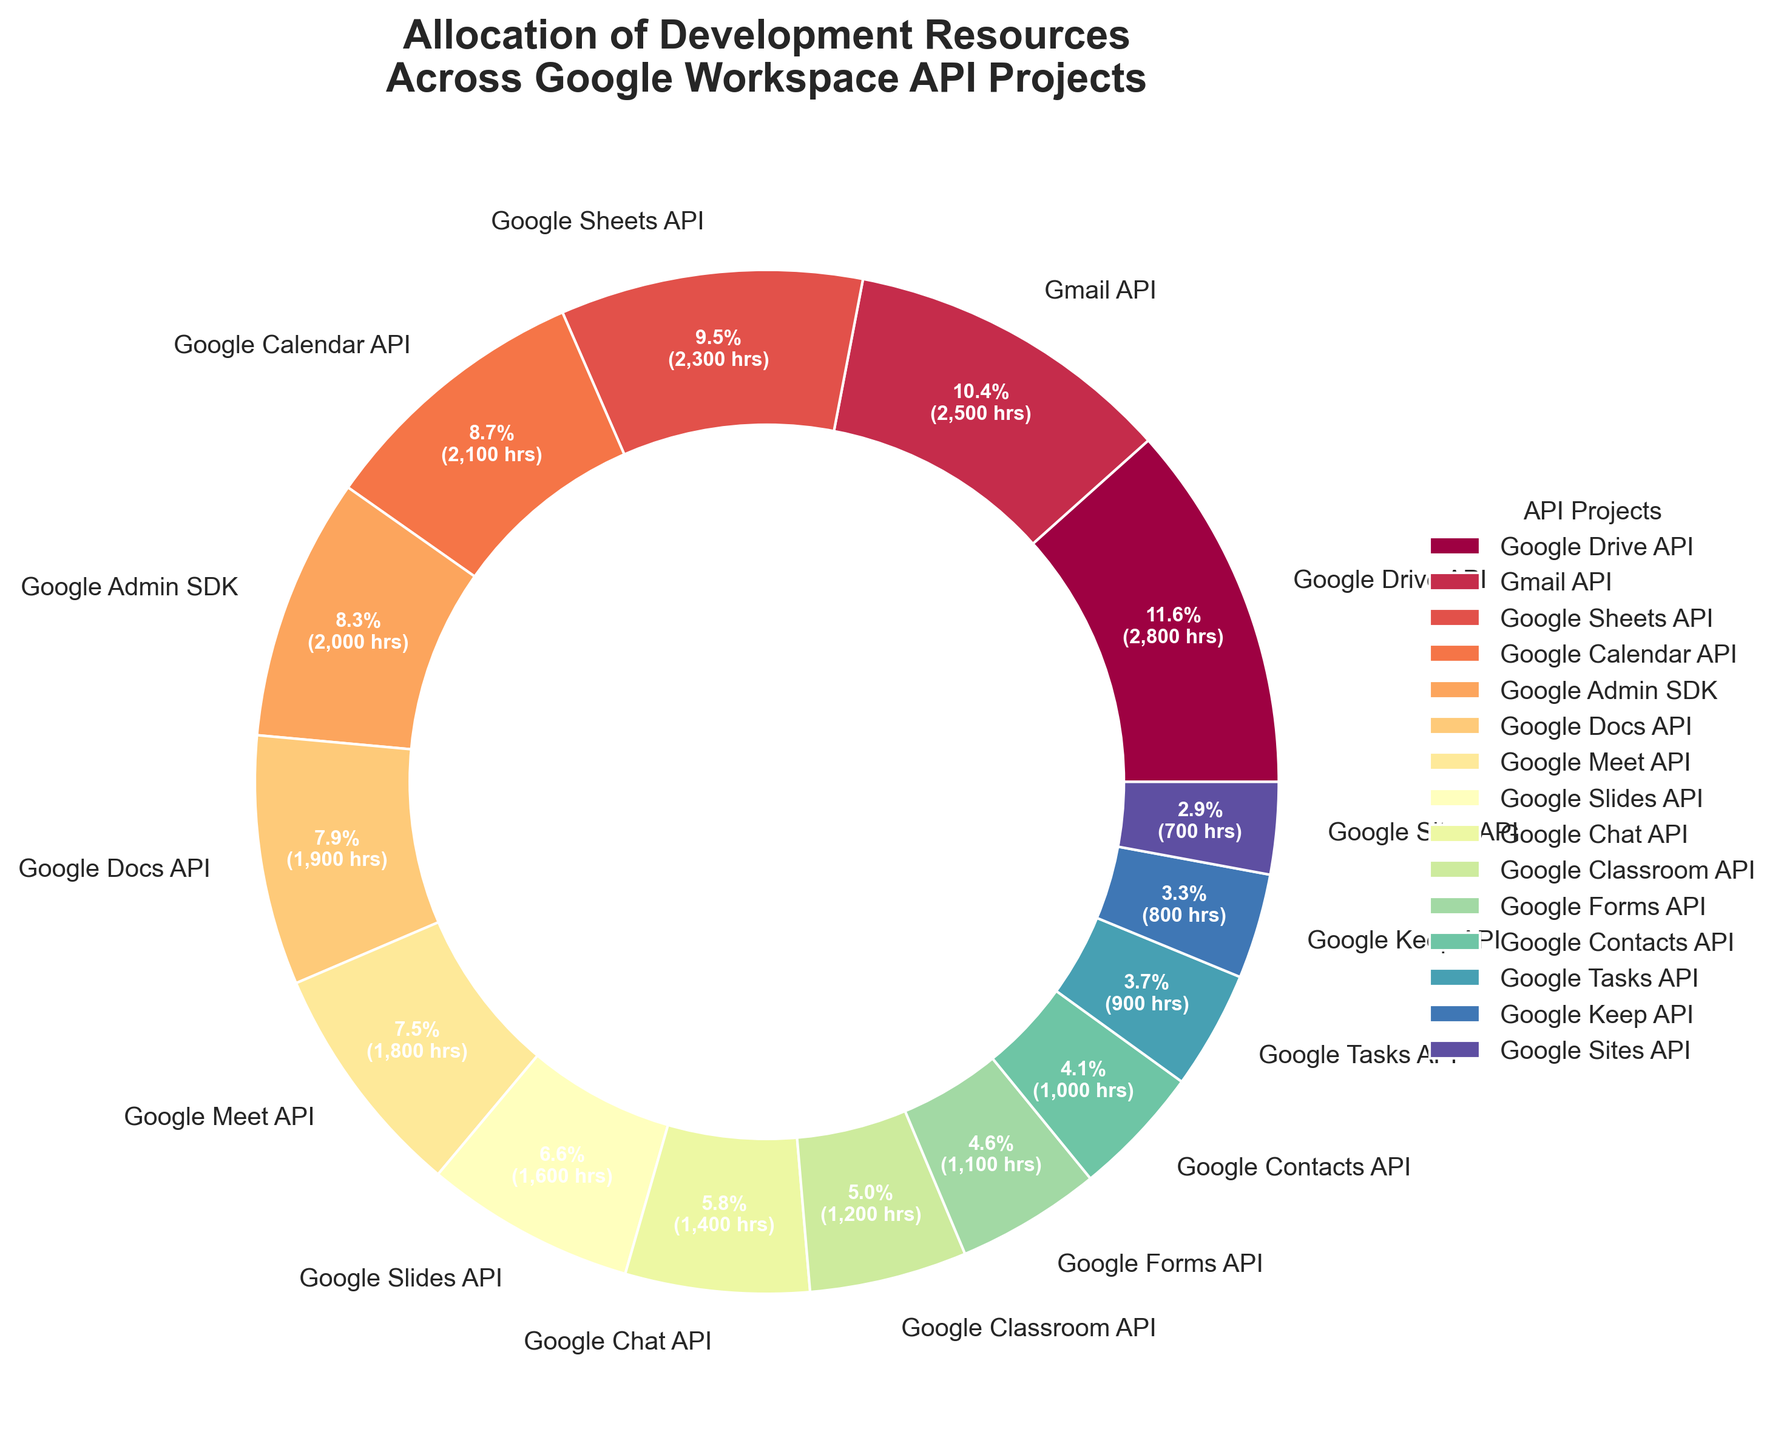Which API project has the largest allocation of development resources? The largest slice in the pie chart corresponds to the API project with the highest development hours.
Answer: Google Drive API Which API project has the smallest allocation of development resources? The smallest slice in the pie chart corresponds to the API project with the lowest development hours.
Answer: Google Sites API How many hours were allocated to the Google Calendar API project? Look at the percentage and hours provided with the Google Calendar API slice.
Answer: 2100 hours Which API project has more development hours, Gmail API or Google Sheets API? Compare the sizes of the slices or the associated hours and percentages for Gmail API and Google Sheets API.
Answer: Gmail API What is the total number of development hours for Google Meet API and Google Classroom API combined? Sum the hours for the Google Meet API (1800) and Google Classroom API (1200).
Answer: 3000 hours Compare the development hours allocated to Google Docs API and Google Admin SDK. Which one has more, and by how much? Check the hours allocated to Google Docs API (1900) and Google Admin SDK (2000), and calculate the difference.
Answer: Google Admin SDK has 100 more hours What fraction of the total development hours is spent on Google Keep API? Calculate the percentage of hours for Google Keep API compared to the total hours (Google Keep API hours / total hours * 100).
Answer: 3.0% Which color corresponds to the Google Slides API slice in the pie chart? Identify the color of the slice labeled Google Slides API.
Answer: [Visuals Needed for Exact Color] What is the average number of development hours per API project? Sum all the development hours and divide by the number of API projects (15).
Answer: 1700 hours If the development hours for Google Sheets API were increased by 200, what would be its new percentage allocation? First, add 200 to the current Google Sheets API hours (2300). Then, recalculate the percentage (new hours / total hours * 100).
Answer: 12.1% 